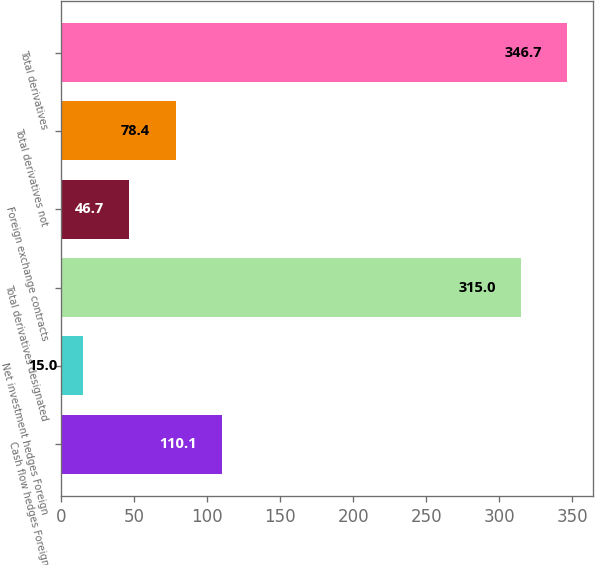<chart> <loc_0><loc_0><loc_500><loc_500><bar_chart><fcel>Cash flow hedges Foreign<fcel>Net investment hedges Foreign<fcel>Total derivatives designated<fcel>Foreign exchange contracts<fcel>Total derivatives not<fcel>Total derivatives<nl><fcel>110.1<fcel>15<fcel>315<fcel>46.7<fcel>78.4<fcel>346.7<nl></chart> 